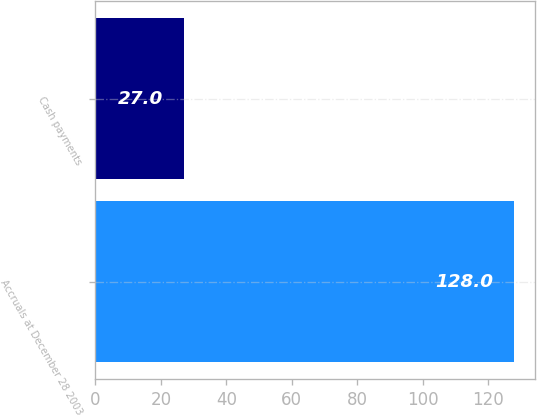<chart> <loc_0><loc_0><loc_500><loc_500><bar_chart><fcel>Accruals at December 28 2003<fcel>Cash payments<nl><fcel>128<fcel>27<nl></chart> 